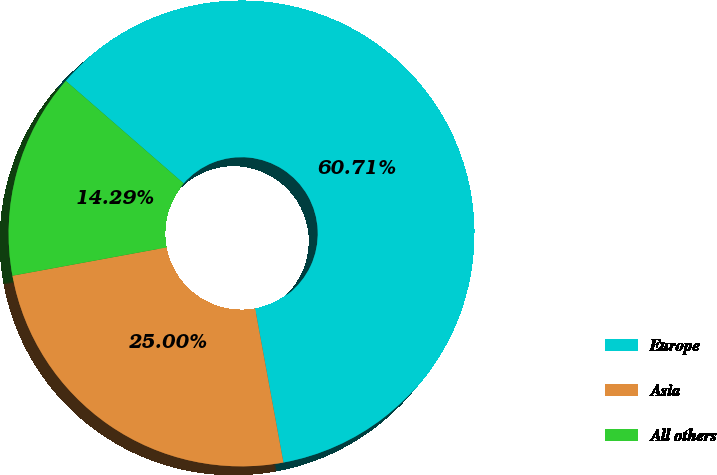Convert chart to OTSL. <chart><loc_0><loc_0><loc_500><loc_500><pie_chart><fcel>Europe<fcel>Asia<fcel>All others<nl><fcel>60.71%<fcel>25.0%<fcel>14.29%<nl></chart> 